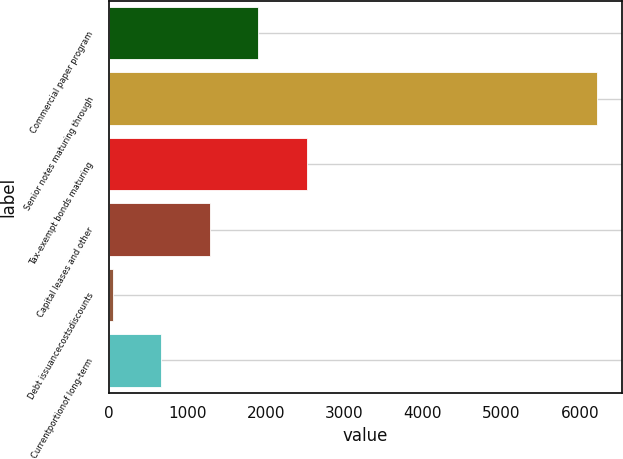<chart> <loc_0><loc_0><loc_500><loc_500><bar_chart><fcel>Commercial paper program<fcel>Senior notes maturing through<fcel>Tax-exempt bonds maturing<fcel>Capital leases and other<fcel>Debt issuancecostsdiscounts<fcel>Currentportionof long-term<nl><fcel>1903<fcel>6222<fcel>2520<fcel>1286<fcel>52<fcel>669<nl></chart> 